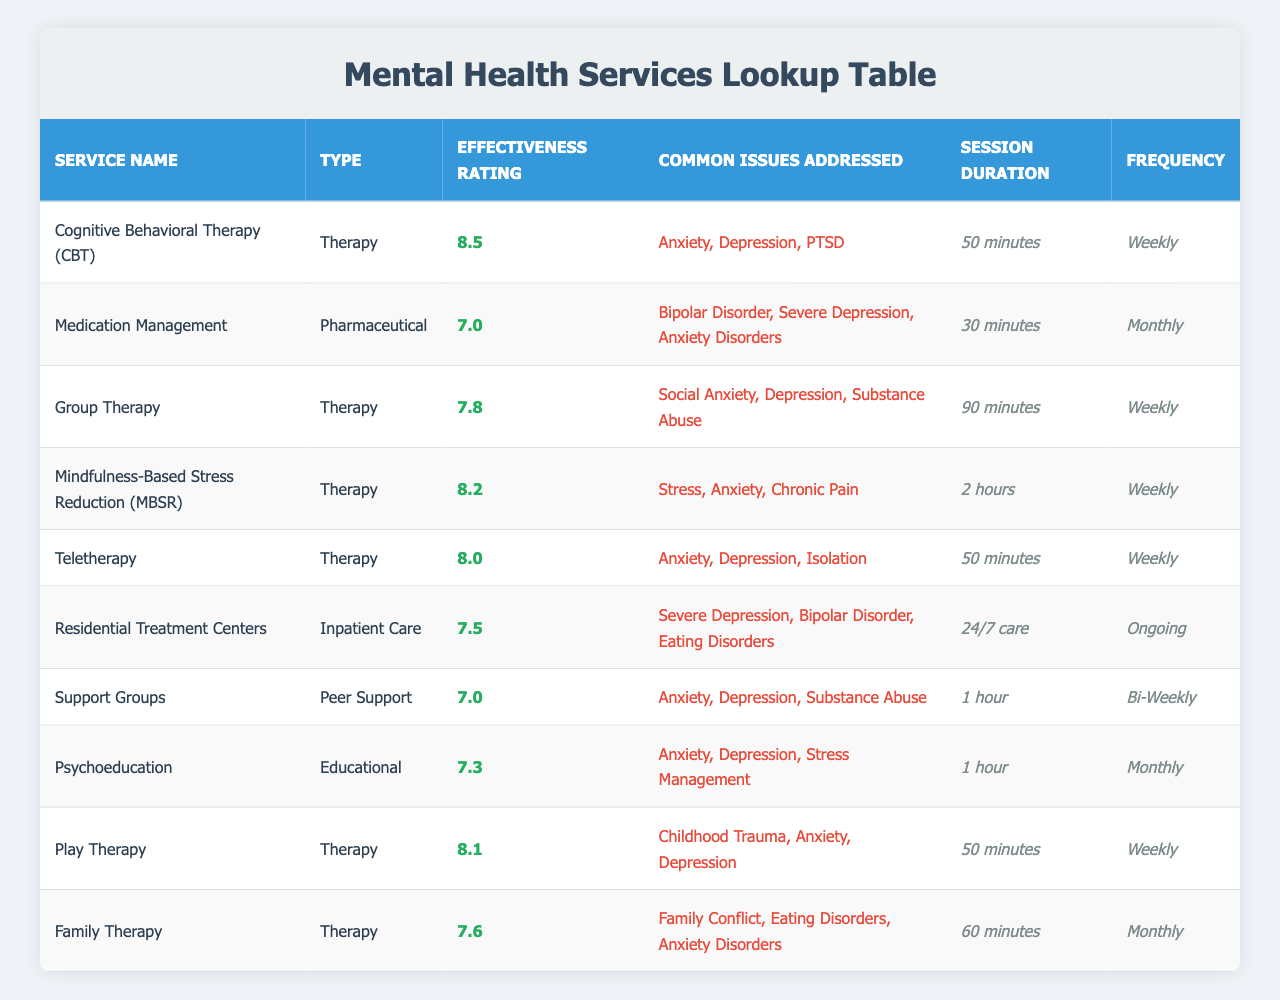What is the effectiveness rating for Cognitive Behavioral Therapy (CBT)? Looking at the table, the effectiveness rating for Cognitive Behavioral Therapy (CBT) is listed directly in the effectiveness rating column next to its name. That value is 8.5.
Answer: 8.5 How often do sessions for Medication Management occur? The table shows the frequency of sessions for Medication Management in the frequency column. It indicates that sessions occur monthly.
Answer: Monthly Which therapy type has the highest effectiveness rating? To find out which therapy type has the highest effectiveness rating, we can compare the values in the effectiveness rating column for all therapy types. After examining the ratings, Cognitive Behavioral Therapy (CBT) stands out with a rating of 8.5, which is the highest among them.
Answer: Cognitive Behavioral Therapy (CBT) Is Mindfulness-Based Stress Reduction (MBSR) effective for stress-related issues? The table indicates that Mindfulness-Based Stress Reduction (MBSR) addresses stress, as shown in the common issues addressed column. The effectiveness rating of 8.2 also suggests that it is considered effective for such issues.
Answer: Yes What is the average effectiveness rating for all the therapy services listed? To find the average effectiveness rating of therapy services, we first identify the effectiveness ratings for each therapy service: CBT (8.5), Group Therapy (7.8), MBSR (8.2), Teletherapy (8.0), Play Therapy (8.1), and Family Therapy (7.6). We sum these values: 8.5 + 7.8 + 8.2 + 8.0 + 8.1 + 7.6 = 48.2. Since there are 6 therapy services, we calculate the average by dividing the total by 6: 48.2 / 6 = 8.03 (rounded to two decimal places).
Answer: 8.03 